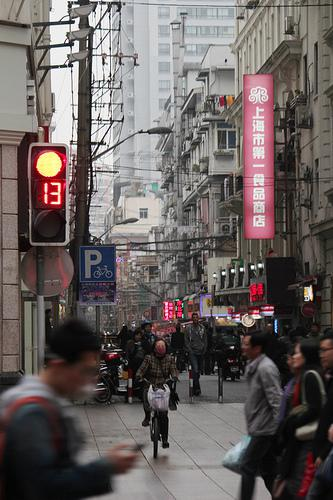Question: what color is the big sign on the right?
Choices:
A. Yellow.
B. White.
C. Green.
D. Red.
Answer with the letter. Answer: D 